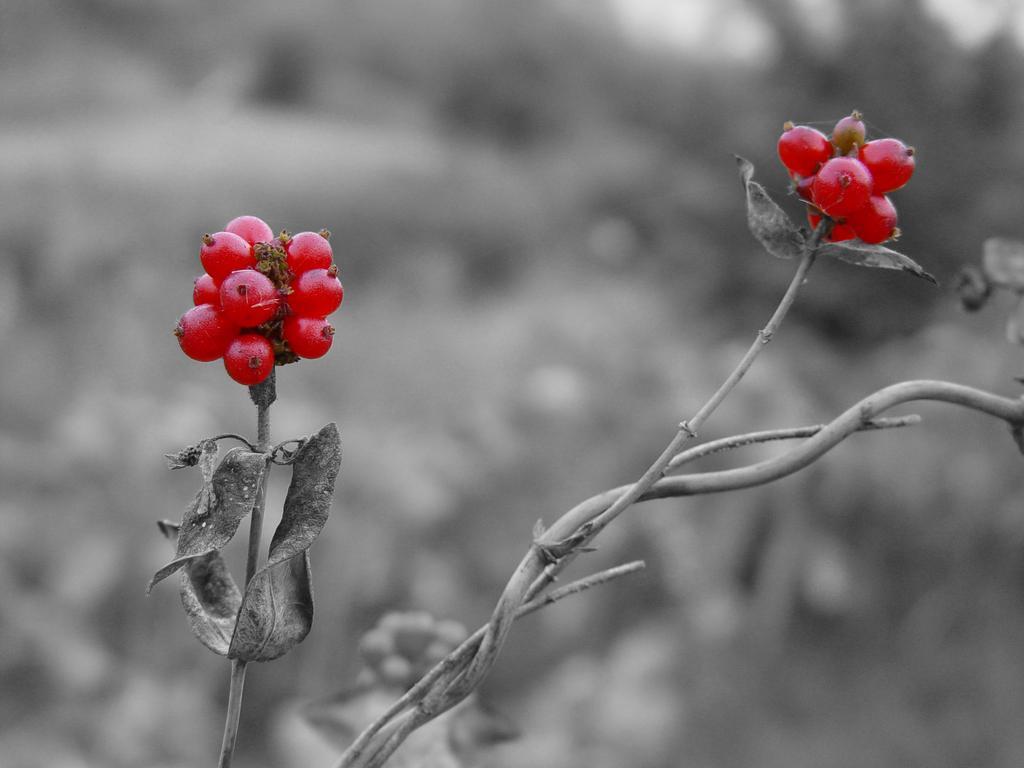Can you describe this image briefly? In this picture we can see a plant with berries. There is a blur background. 